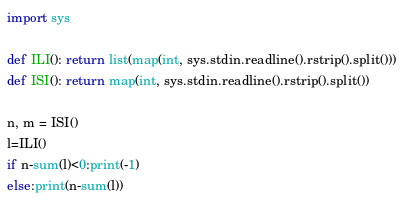Convert code to text. <code><loc_0><loc_0><loc_500><loc_500><_Python_>import sys

def ILI(): return list(map(int, sys.stdin.readline().rstrip().split()))
def ISI(): return map(int, sys.stdin.readline().rstrip().split())

n, m = ISI()
l=ILI()
if n-sum(l)<0:print(-1)
else:print(n-sum(l))</code> 